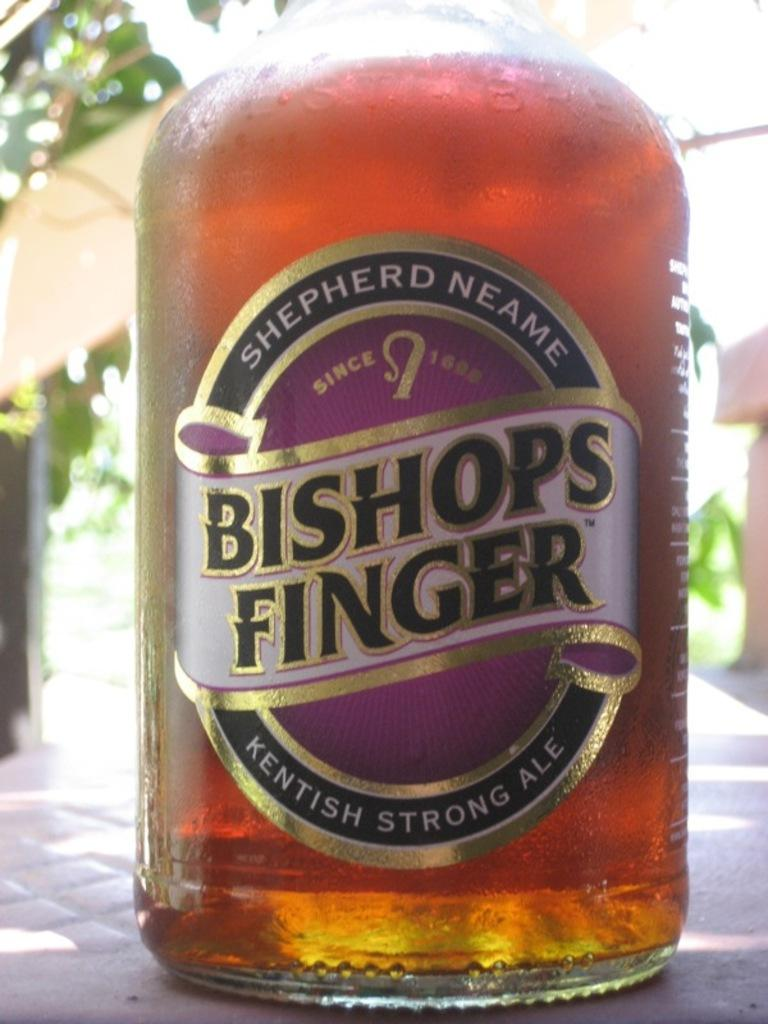<image>
Describe the image concisely. a bottle with the word Bishops Finger on it 